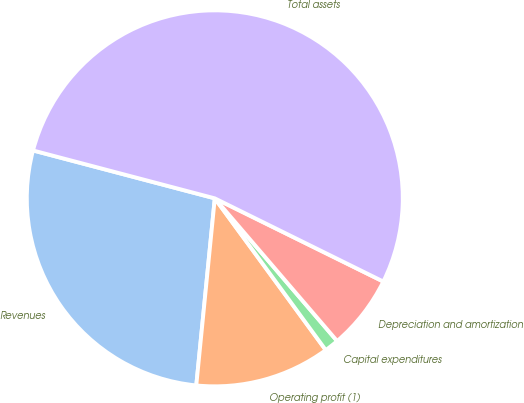Convert chart to OTSL. <chart><loc_0><loc_0><loc_500><loc_500><pie_chart><fcel>Revenues<fcel>Operating profit (1)<fcel>Capital expenditures<fcel>Depreciation and amortization<fcel>Total assets<nl><fcel>27.53%<fcel>11.62%<fcel>1.23%<fcel>6.42%<fcel>53.2%<nl></chart> 